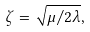Convert formula to latex. <formula><loc_0><loc_0><loc_500><loc_500>\zeta = \sqrt { \mu / 2 \lambda } ,</formula> 